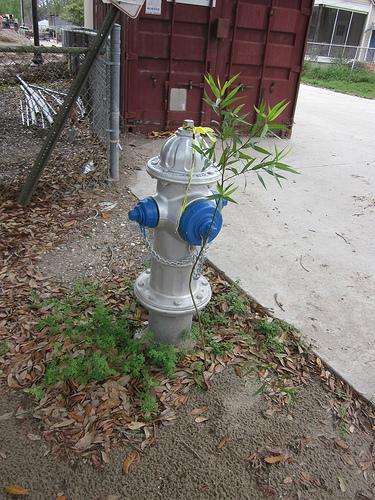How many hydrants are present in the image and what are their colors? There is one hydrant in the image and it is silver and blue. Count the number of items that can be collectively described as "chains on the hydrant" and give the sum of their widths. There are 4 items described as chains on the hydrant, with a total sum of widths equal to 266. Create a short story about a silver and blue fire hydrant saving the house in the background. Once upon a time in a quiet neighborhood, a silver and blue fire hydrant stood diligently guarding the area. One day, a fierce fire broke out in the house nearby. Firefighters soon arrived and connected their hoses to the hydrant. With water gushing forth, they quickly doused the flames, saving the house from utter destruction. The grateful residents rejoiced, and the silver and blue hydrant continued its silent vigil, always ready to protect its community. Can you find the red and yellow fire hydrant? This instruction is misleading because the fire hydrant in the image is silver and blue, not red and yellow. Is there a person standing near the chain-link fence? No, it's not mentioned in the image. Identify the text on the white and red sign. Unable to identify the text as it's not provided. Against disasters, it always works hard. Together they stand and conquer this land. Identify the underlying situation with the tipped street sign in relation to the hydrant. The situation suggests some recent disruption, possibly from a storm, accident, or vandalism. Are the leaves alive or dead and mention their color? The leaves are dead and brown in color. Compose a poem about the sunroom beyond the fence and the silver and blue hydrant. Behind the fence, there lies a sunroom, Visualize the position of the cement next to the hydrant and explain the surroundings. The cement is situated adjacent to the hydrant, providing a solid ground for it to rest on. It's surrounded by dirt, leaves, and greenery. List the objects depicted in the scene with the driveway. Gray driveway, silver and blue hydrant, chain link fence, leaves, and green plants. Are there any human faces in the image and if so, how do they look? There are no human faces in the image. Describe the appearance of the chain link fence and its relation to the hydrant. The chain link fence appears sturdy with a metallic finish. It is situated close to the silver and blue hydrant but they don't seem to be directly connected. Describe the scene of the silver and blue hydrant with surrounding objects like chains, leaves, and fence with an artistic touch. A silver and blue hydrant stands majestically, its vibrant colors contrasting the dull background. Twisted chains wrap around it like an embrace, while autumn leaves gently blanket the ground. A sturdy chain link fence looms nearby, adding a touch of urbanity to the scene. Write a sentence describing the weather, based on raindrops denting the ground. It appears to have been raining recently, leaving small dents on the wet ground. What can we infer from the tall weeds growing along the side? The area is not well-maintained or landscaped. Explain if the hydrant is in or above the ground. The hydrant is in the ground. Describe the human expressions in the scene with the silver fire hydrant and the blue plugs. There are no human expressions in the scene. Arrange the information related to the iron poles into a simple diagram with their position and relation to the fence. Iron poles are located behind the fence, in a horizontal position. Is there a green storage container next to the maroon dumpster? This instruction is misleading because the storage container described in the image is maroon, not green. Determine the event occurring in the scene with the tipped street sign and the hydrant. A possible event could be recent storm damage or vandalism. Which of these best describes the color of the hydrant? A) Silver and blue B) Red and white C) Green and brown D) Yellow and orange A) Silver and blue What activity can be inferred from the presence of the maroon dumpster and storage container? Storing or disposing of materials or items. Given the different captions for the same object, determine whether it's a fact or an opinion: "The hydrant is silver and blue." Fact 